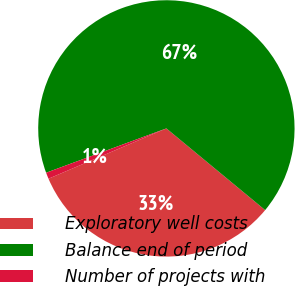Convert chart to OTSL. <chart><loc_0><loc_0><loc_500><loc_500><pie_chart><fcel>Exploratory well costs<fcel>Balance end of period<fcel>Number of projects with<nl><fcel>32.58%<fcel>66.62%<fcel>0.8%<nl></chart> 